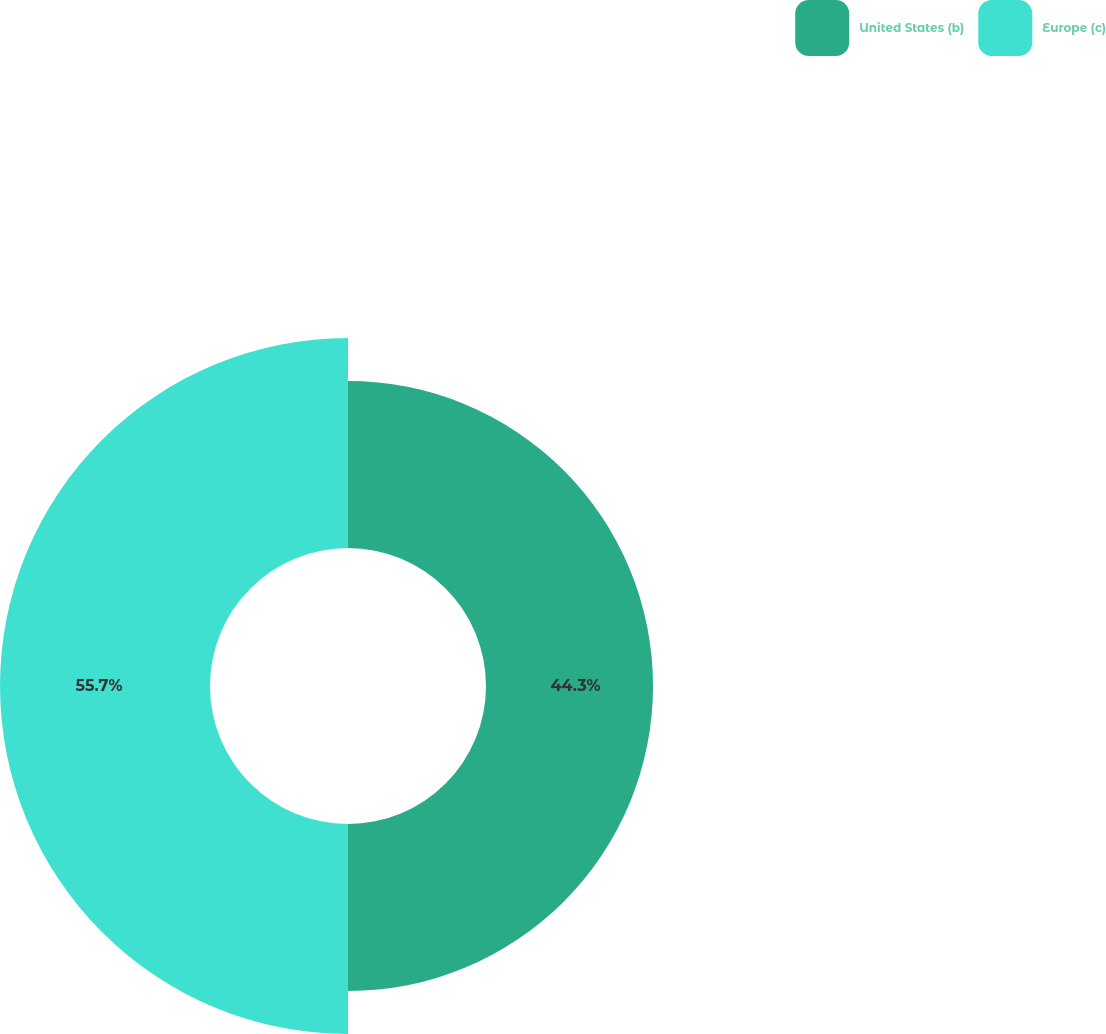Convert chart. <chart><loc_0><loc_0><loc_500><loc_500><pie_chart><fcel>United States (b)<fcel>Europe (c)<nl><fcel>44.3%<fcel>55.7%<nl></chart> 